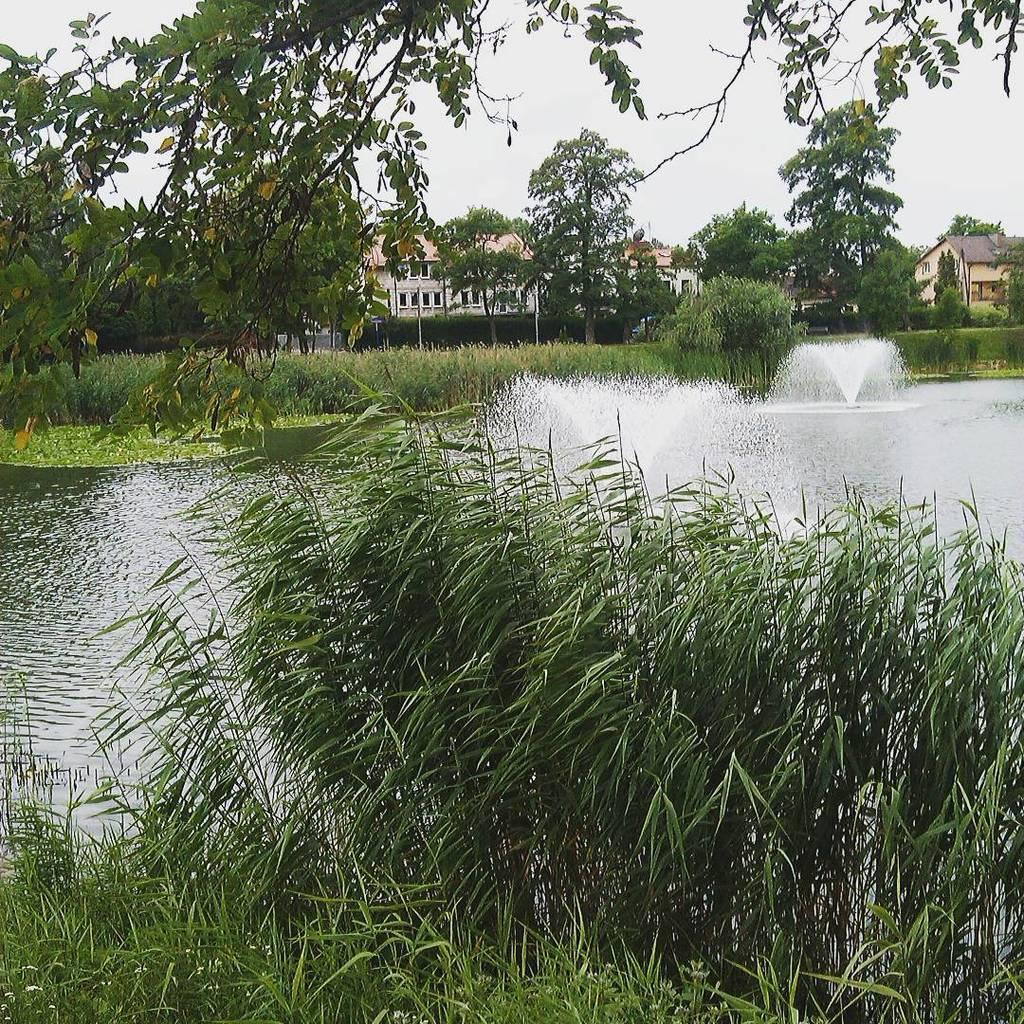What type of living organisms can be seen in the image? Plants and trees are visible in the image. What natural element is present in the image? Water is visible in the image. What type of structures can be seen in the image? There are buildings in the image. What is visible in the background of the image? The sky is visible in the background of the image. What type of industry can be seen in the image? There is no industry present in the image. Can you see a brake in the image? There is no brake present in the image. 